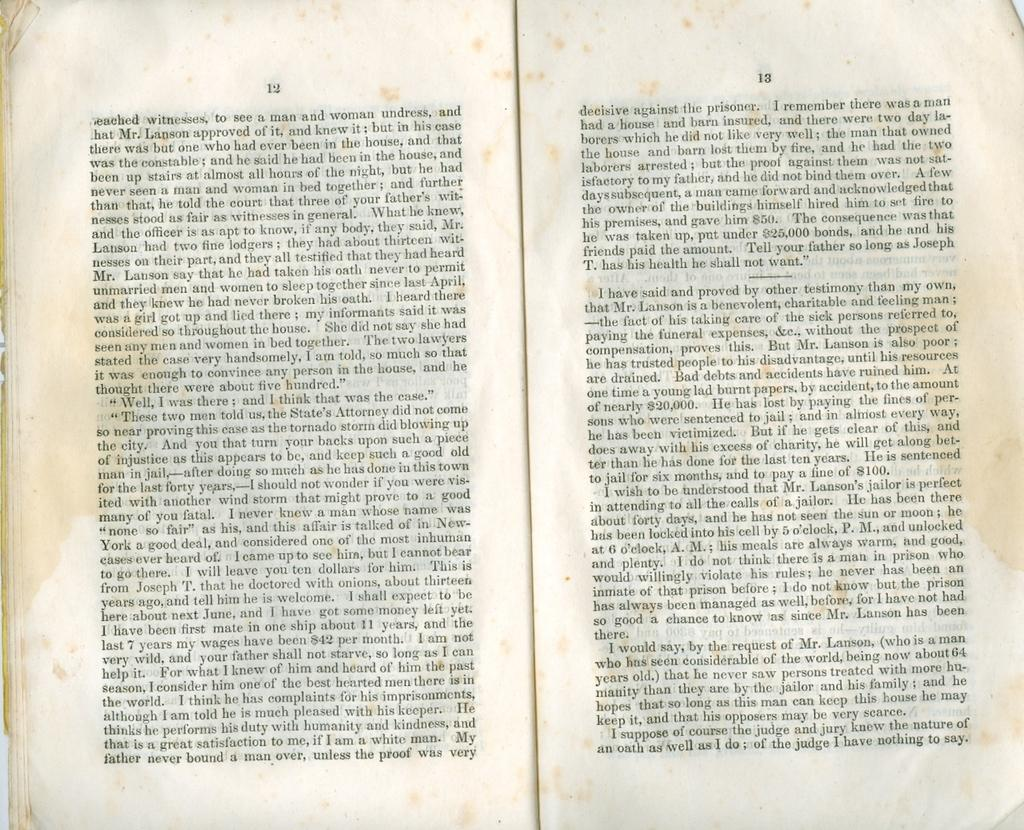What type of object is featured in the image? There are two pages of an old book in the image. What can be found on the pages of the book? There are sentences and numbers written on the pages. What type of vest is visible on the pages of the book? There is no vest present on the pages of the book; the image only features text in the form of sentences and numbers. 